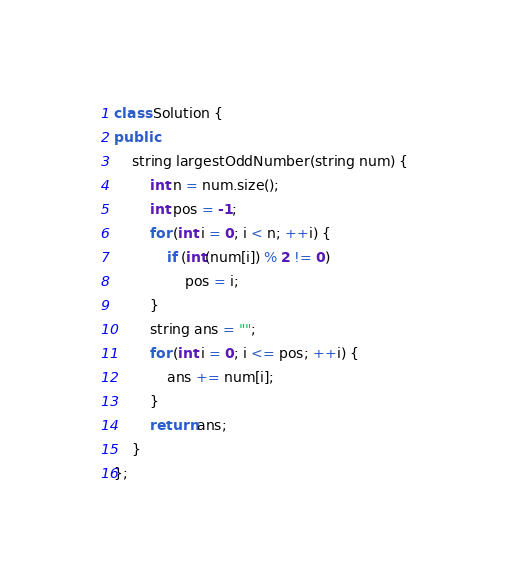Convert code to text. <code><loc_0><loc_0><loc_500><loc_500><_C++_>class Solution {
public:
    string largestOddNumber(string num) {
        int n = num.size(); 
        int pos = -1; 
        for (int i = 0; i < n; ++i) {
            if (int(num[i]) % 2 != 0) 
                pos = i; 
        }
        string ans = ""; 
        for (int i = 0; i <= pos; ++i) {
            ans += num[i]; 
        }
        return ans; 
    }
};</code> 